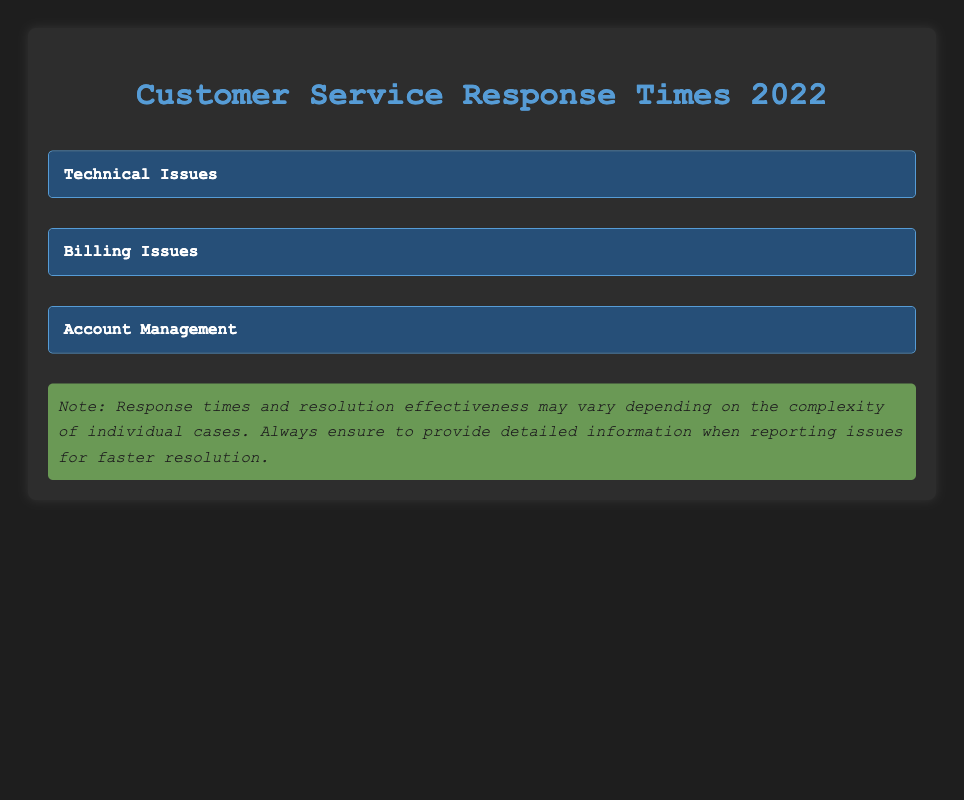What is the average response time for a billing issue related to an incorrect charge? The table states that the average response time for an "Incorrect Charge" under "Billing Issues" is "1 hour."
Answer: 1 hour Which issue type has the longest average response time? By comparing the average response times across all categories (Technical Issues, Billing Issues, Account Management), "Payment Dispute" under "Billing Issues" has the longest response time of "5 hours."
Answer: Payment Dispute Is the resolution effectiveness for "Software Bug" classified as high? According to the table, "Software Bug" has a resolution effectiveness classified as "High."
Answer: Yes What is the average response time for issues with medium resolution effectiveness? The response times for issues with medium resolution effectiveness are "4 hours" (Hardware Malfunction), "3 hours" (Refund Request), and "2 hours" (Profile Update). Adding these gives 4 + 3 + 2 = 9 hours. Dividing by the number of issues (3) results in an average of 9/3 = 3 hours.
Answer: 3 hours Which issue in Account Management has the shortest response time? The table shows that "Account Access" has a response time of "30 minutes," while "Profile Update" has "2 hours." Therefore, "Account Access" is the shortest.
Answer: Account Access How many issues in the table have high resolution effectiveness? There are 5 issues with high resolution effectiveness: "Software Bug," "Connectivity Problems," "Incorrect Charge," and "Account Access." The total is 4.
Answer: 4 What is the combined average response time of all technical issues? The average response times for technical issues are 2 hours (Software Bug), 4 hours (Hardware Malfunction), and 3 hours (Connectivity Problems). First, convert hours to minutes: 2 hours = 120 minutes, 4 hours = 240 minutes, and 3 hours = 180 minutes. Adding these gives 120 + 240 + 180 = 540 minutes. Then divide by the number of issues (3), resulting in 540/3 = 180 minutes, which converts back to 3 hours.
Answer: 3 hours Are there any billing issues that have low resolution effectiveness? The table lists "Payment Dispute" under "Billing Issues" with a resolution effectiveness of "Low." Hence, there is a billing issue with low effectiveness.
Answer: Yes 